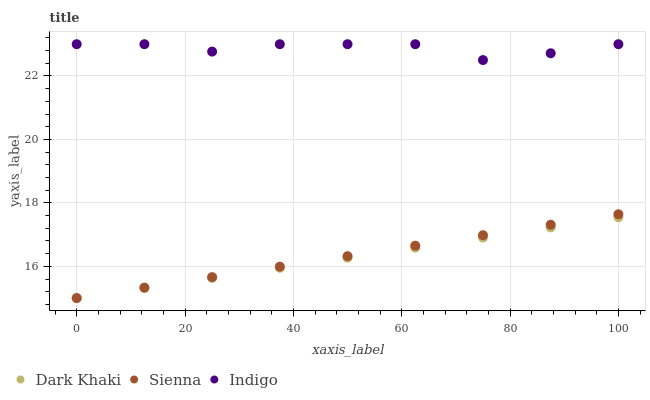Does Dark Khaki have the minimum area under the curve?
Answer yes or no. Yes. Does Indigo have the maximum area under the curve?
Answer yes or no. Yes. Does Sienna have the minimum area under the curve?
Answer yes or no. No. Does Sienna have the maximum area under the curve?
Answer yes or no. No. Is Sienna the smoothest?
Answer yes or no. Yes. Is Indigo the roughest?
Answer yes or no. Yes. Is Indigo the smoothest?
Answer yes or no. No. Is Sienna the roughest?
Answer yes or no. No. Does Dark Khaki have the lowest value?
Answer yes or no. Yes. Does Indigo have the lowest value?
Answer yes or no. No. Does Indigo have the highest value?
Answer yes or no. Yes. Does Sienna have the highest value?
Answer yes or no. No. Is Sienna less than Indigo?
Answer yes or no. Yes. Is Indigo greater than Sienna?
Answer yes or no. Yes. Does Dark Khaki intersect Sienna?
Answer yes or no. Yes. Is Dark Khaki less than Sienna?
Answer yes or no. No. Is Dark Khaki greater than Sienna?
Answer yes or no. No. Does Sienna intersect Indigo?
Answer yes or no. No. 